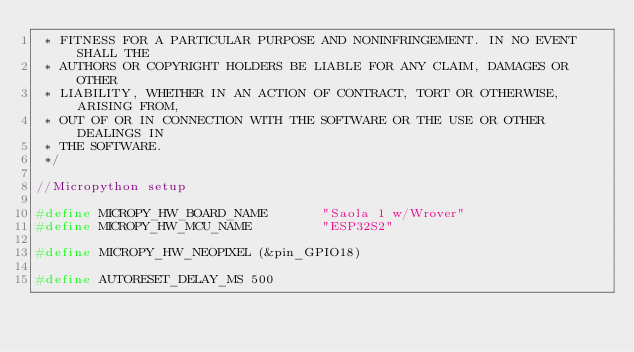<code> <loc_0><loc_0><loc_500><loc_500><_C_> * FITNESS FOR A PARTICULAR PURPOSE AND NONINFRINGEMENT. IN NO EVENT SHALL THE
 * AUTHORS OR COPYRIGHT HOLDERS BE LIABLE FOR ANY CLAIM, DAMAGES OR OTHER
 * LIABILITY, WHETHER IN AN ACTION OF CONTRACT, TORT OR OTHERWISE, ARISING FROM,
 * OUT OF OR IN CONNECTION WITH THE SOFTWARE OR THE USE OR OTHER DEALINGS IN
 * THE SOFTWARE.
 */

//Micropython setup

#define MICROPY_HW_BOARD_NAME       "Saola 1 w/Wrover"
#define MICROPY_HW_MCU_NAME         "ESP32S2"

#define MICROPY_HW_NEOPIXEL (&pin_GPIO18)

#define AUTORESET_DELAY_MS 500
</code> 